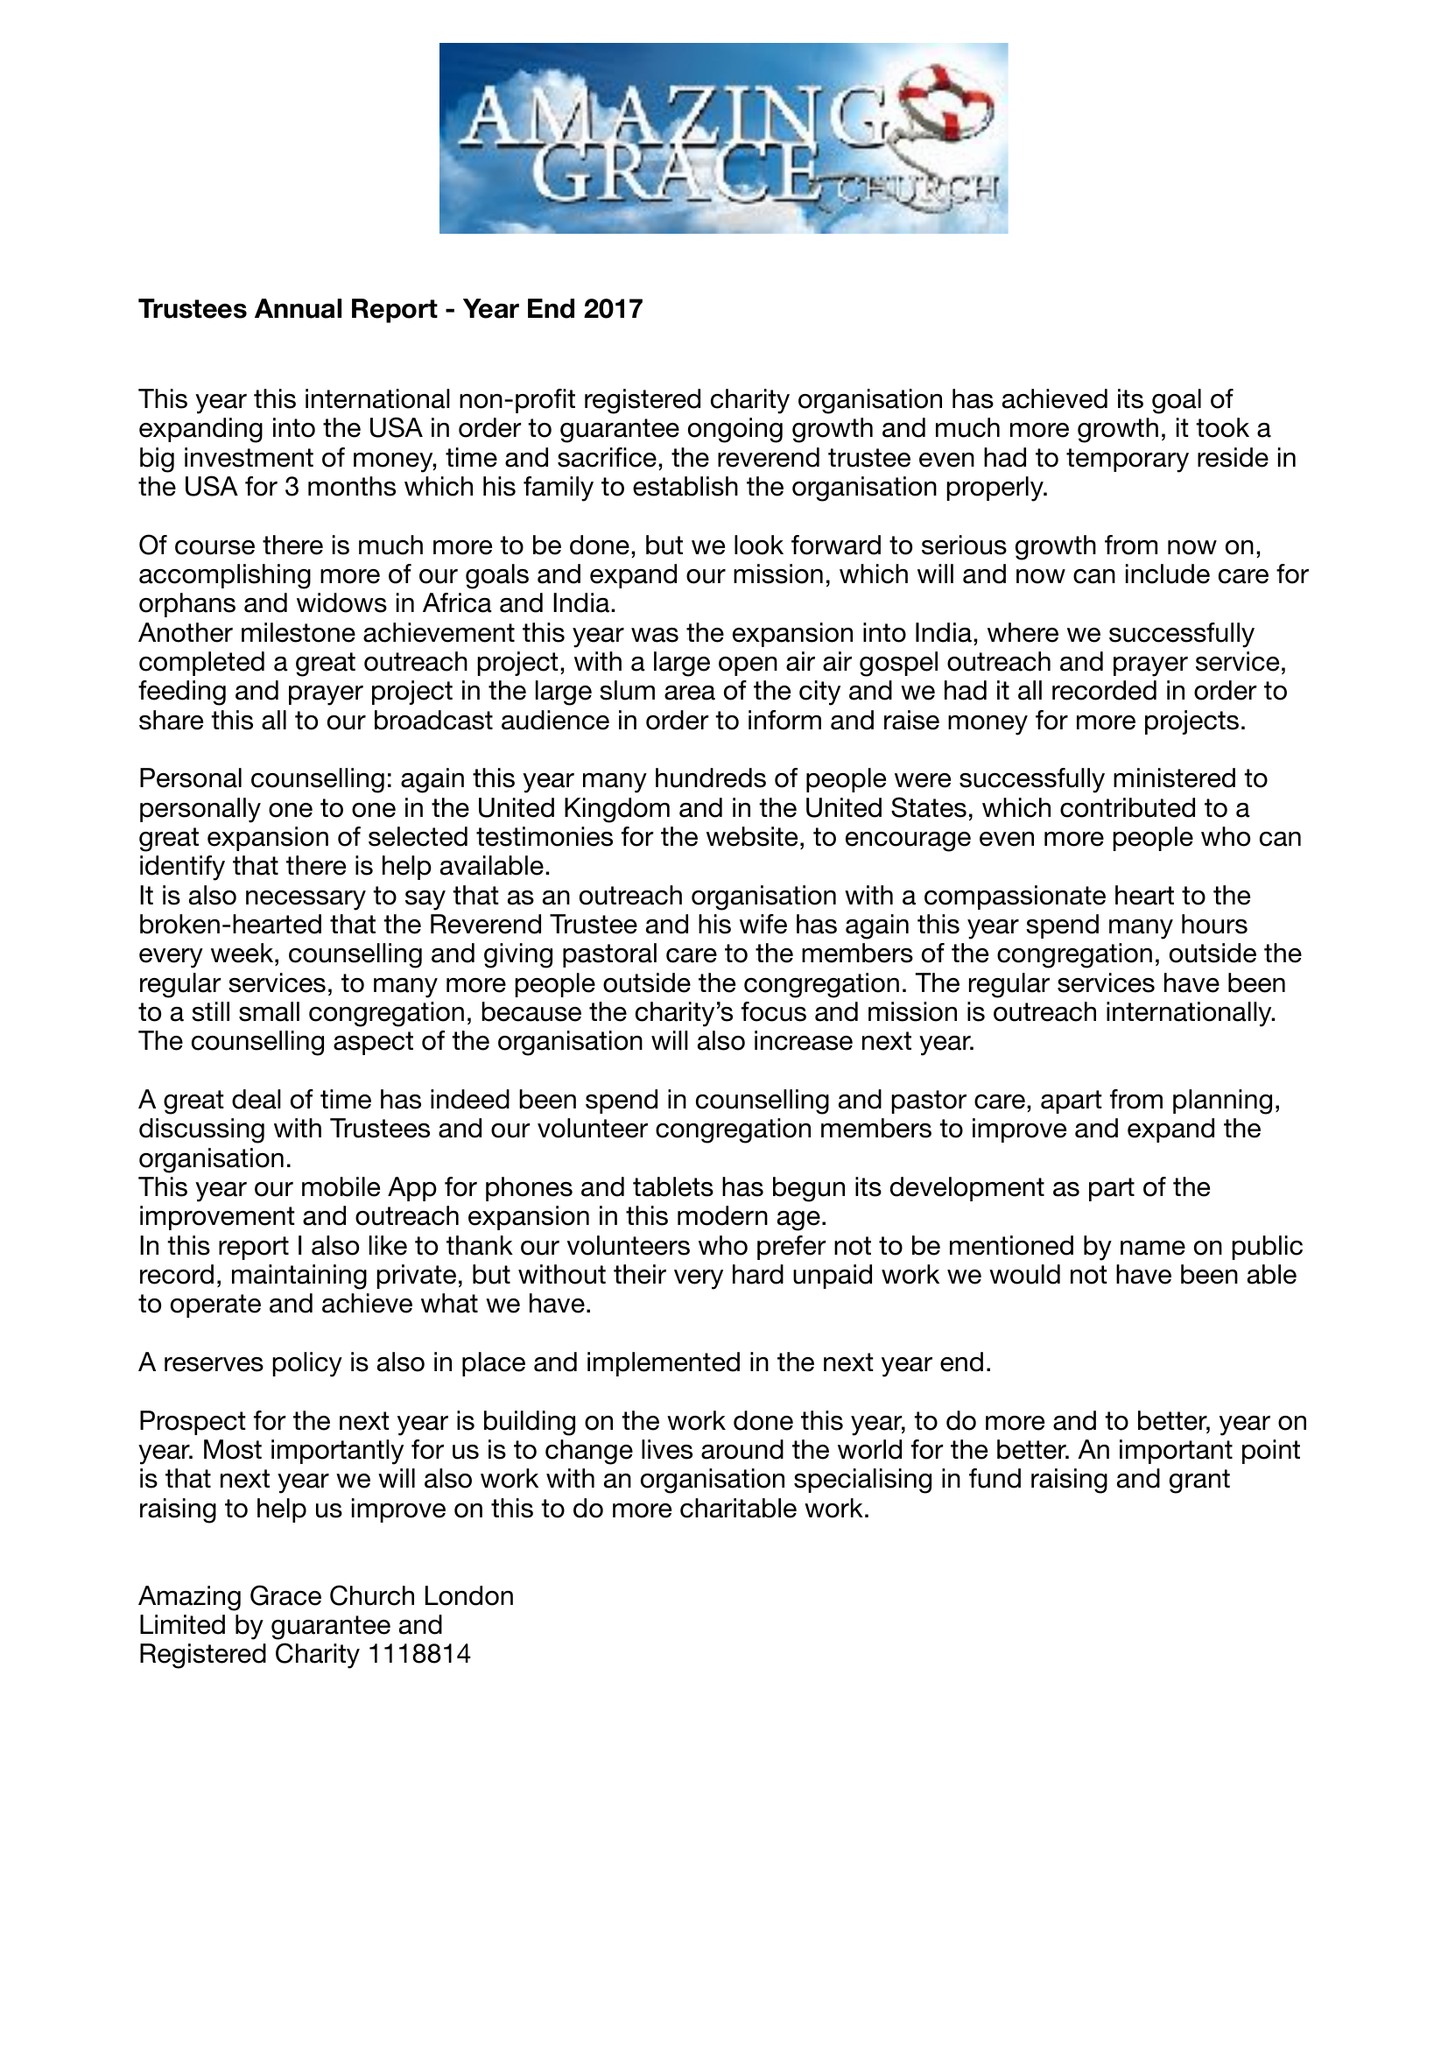What is the value for the income_annually_in_british_pounds?
Answer the question using a single word or phrase. 80710.00 